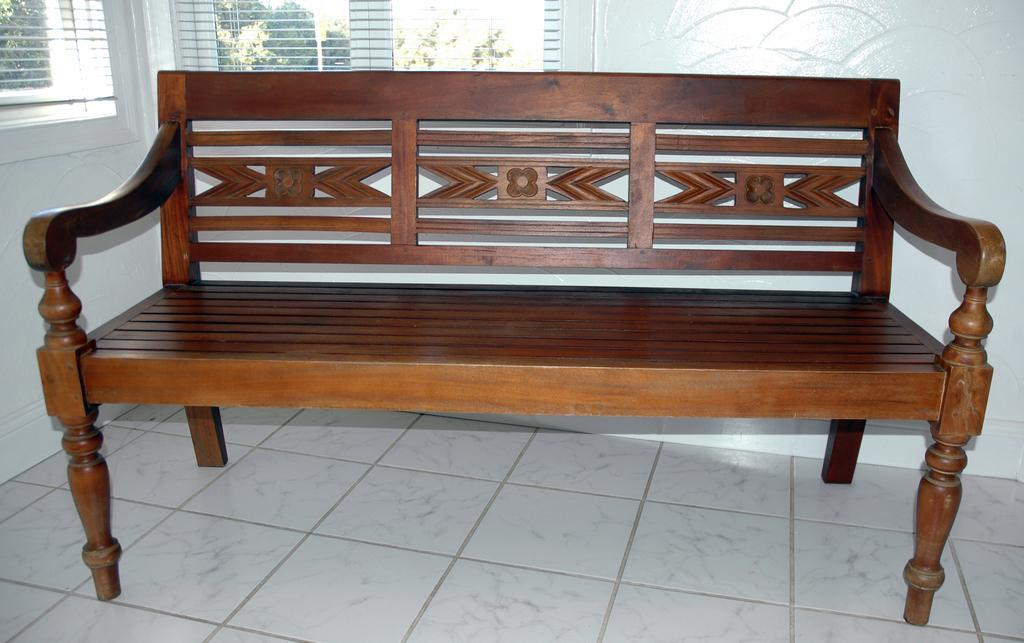What is located in the foreground of the image? There is a bench in the foreground of the image. Where is the bench positioned? The bench is on the floor. What can be seen in the background of the image? There is a wall and two windows in the background of the image. What type of loaf is being served at the feast in the image? There is no feast or loaf present in the image; it features a bench on the floor with a wall and two windows in the background. 